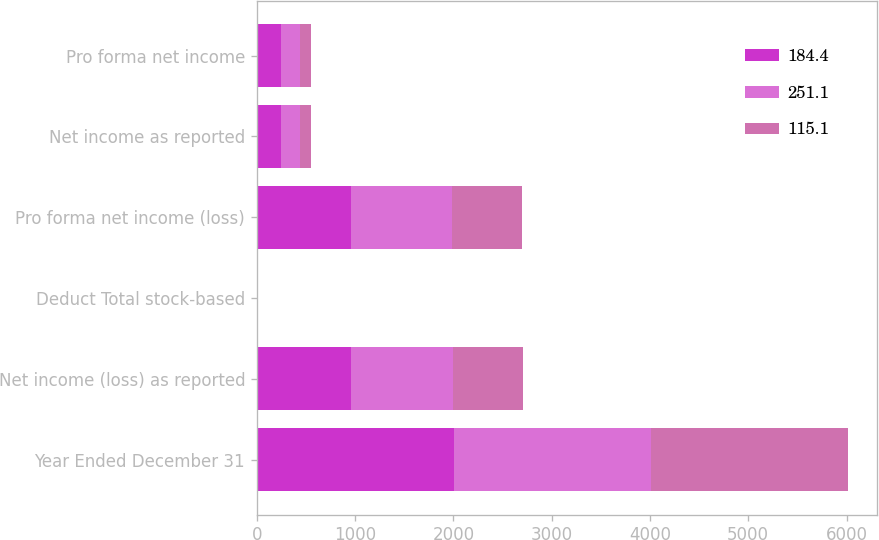<chart> <loc_0><loc_0><loc_500><loc_500><stacked_bar_chart><ecel><fcel>Year Ended December 31<fcel>Net income (loss) as reported<fcel>Deduct Total stock-based<fcel>Pro forma net income (loss)<fcel>Net income as reported<fcel>Pro forma net income<nl><fcel>184.4<fcel>2005<fcel>960.3<fcel>5.4<fcel>954.9<fcel>251.3<fcel>251.1<nl><fcel>251.1<fcel>2004<fcel>1031.3<fcel>5.2<fcel>1026.1<fcel>184.5<fcel>184.4<nl><fcel>115.1<fcel>2003<fcel>712.4<fcel>5.5<fcel>717.9<fcel>115.2<fcel>115.1<nl></chart> 